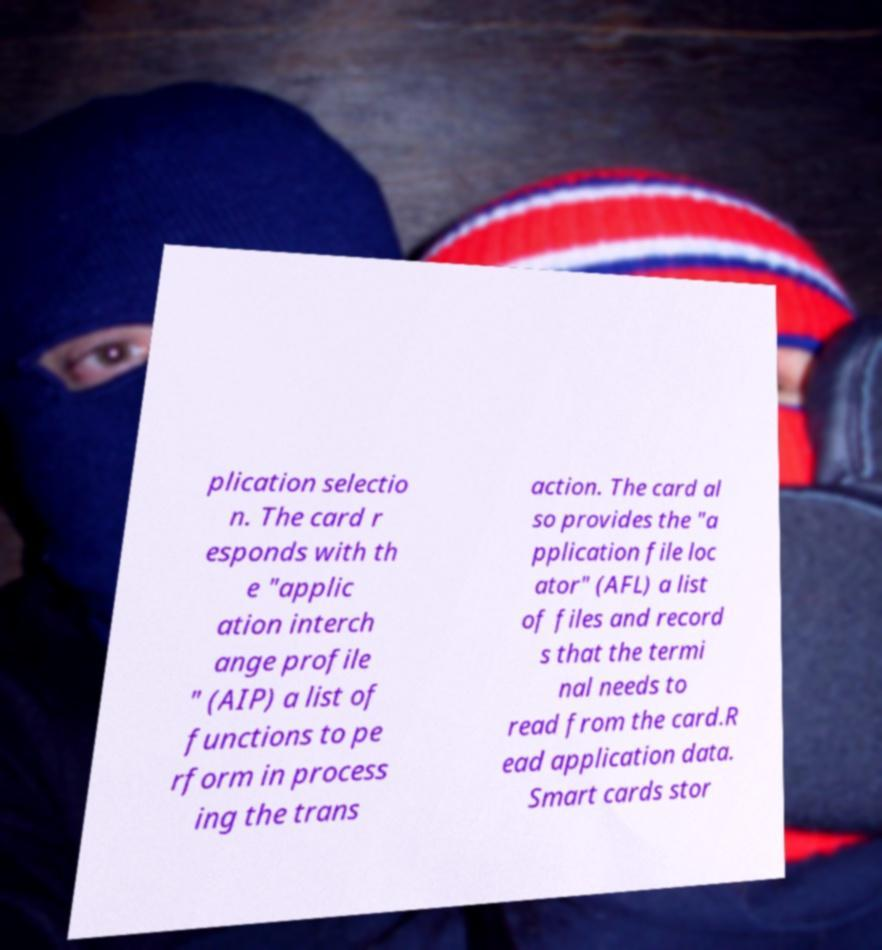For documentation purposes, I need the text within this image transcribed. Could you provide that? plication selectio n. The card r esponds with th e "applic ation interch ange profile " (AIP) a list of functions to pe rform in process ing the trans action. The card al so provides the "a pplication file loc ator" (AFL) a list of files and record s that the termi nal needs to read from the card.R ead application data. Smart cards stor 